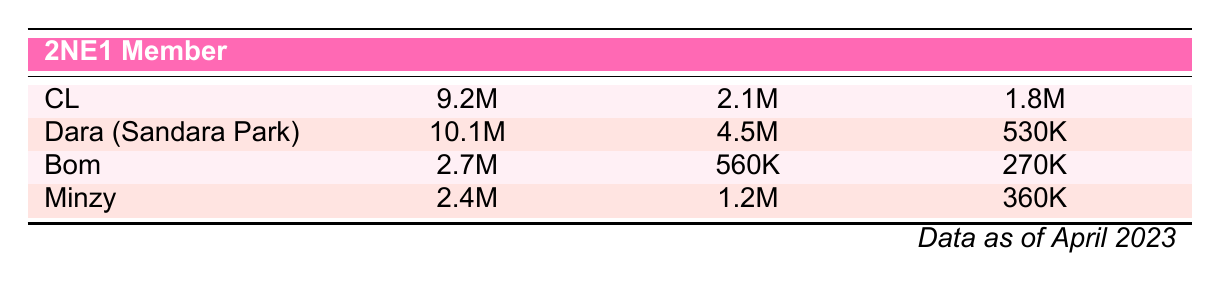What is the highest number of Instagram followers among the 2NE1 members? Dara (Sandara Park) has the most Instagram followers at 10.1M, which is displayed in the second row of the table.
Answer: 10.1M Which member has the lowest number of YouTube subscribers? Among the 2NE1 members, Bom has the lowest number of YouTube subscribers at 270K, noted in the third row.
Answer: 270K How many more Twitter followers does Dara have compared to Minzy? Dara has 4.5M Twitter followers, while Minzy has 1.2M. The difference is calculated as 4.5M - 1.2M = 3.3M.
Answer: 3.3M Is the total number of Instagram followers for CL and Bom greater than that for Minzy? The Instagram followers for CL and Bom are 9.2M and 2.7M respectively, making a total of 9.2M + 2.7M = 11.9M. Minzy has 2.4M. Since 11.9M is greater than 2.4M, the statement is true.
Answer: Yes What is the average number of Twitter followers for all 2NE1 members? To find the average, sum the Twitter followers: 2.1M + 4.5M + 0.56M + 1.2M = 8.36M. There are four members, so the average is 8.36M divided by 4, which equals 2.09M.
Answer: 2.09M Which member has the highest number of YouTube subscribers? CL has the highest number of YouTube subscribers at 1.8M, as shown in the first row of the table.
Answer: 1.8M Does Minzy have more Instagram followers than Bom? Minzy has 2.4M Instagram followers, while Bom has 2.7M. Since 2.4M is less than 2.7M, the statement is false.
Answer: No What is the combined total number of Instagram followers for all members? To find the total, sum the Instagram followers: 9.2M + 10.1M + 2.7M + 2.4M = 24.4M.
Answer: 24.4M 